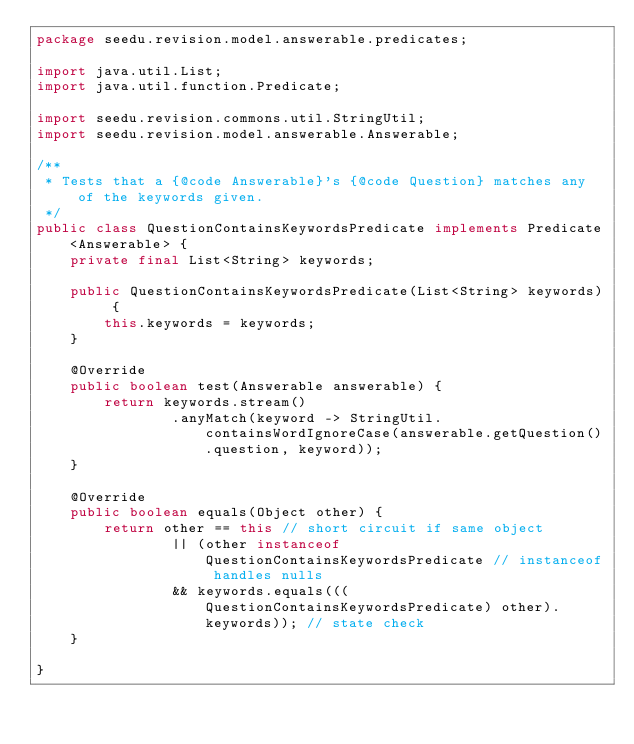Convert code to text. <code><loc_0><loc_0><loc_500><loc_500><_Java_>package seedu.revision.model.answerable.predicates;

import java.util.List;
import java.util.function.Predicate;

import seedu.revision.commons.util.StringUtil;
import seedu.revision.model.answerable.Answerable;

/**
 * Tests that a {@code Answerable}'s {@code Question} matches any of the keywords given.
 */
public class QuestionContainsKeywordsPredicate implements Predicate<Answerable> {
    private final List<String> keywords;

    public QuestionContainsKeywordsPredicate(List<String> keywords) {
        this.keywords = keywords;
    }

    @Override
    public boolean test(Answerable answerable) {
        return keywords.stream()
                .anyMatch(keyword -> StringUtil.containsWordIgnoreCase(answerable.getQuestion().question, keyword));
    }

    @Override
    public boolean equals(Object other) {
        return other == this // short circuit if same object
                || (other instanceof QuestionContainsKeywordsPredicate // instanceof handles nulls
                && keywords.equals(((QuestionContainsKeywordsPredicate) other).keywords)); // state check
    }

}
</code> 